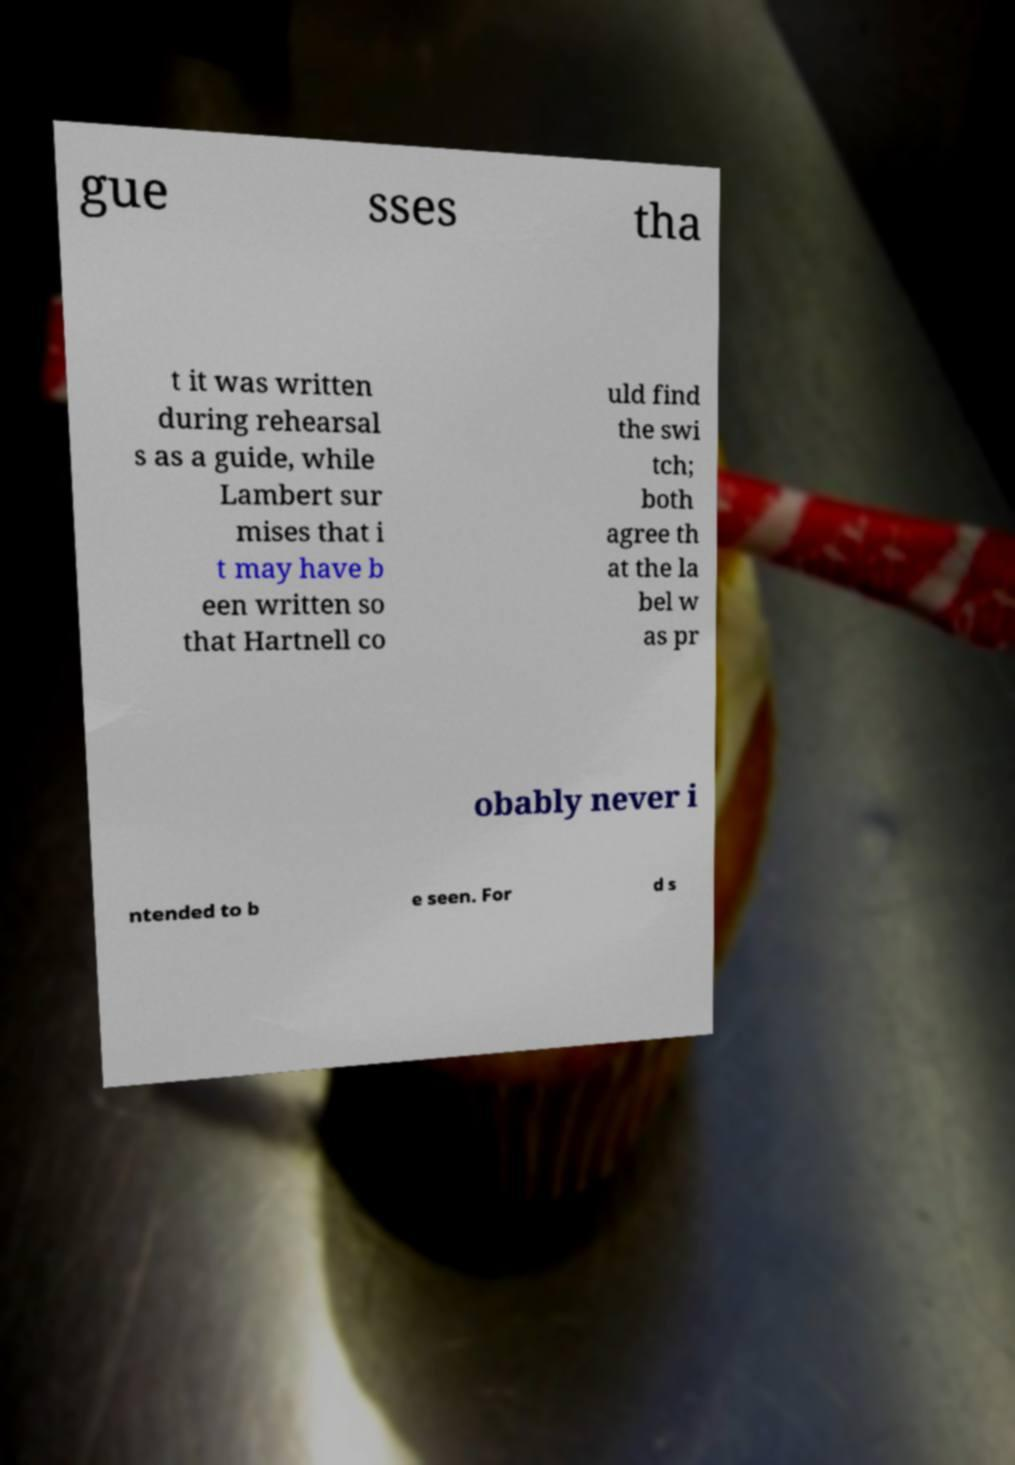Please identify and transcribe the text found in this image. gue sses tha t it was written during rehearsal s as a guide, while Lambert sur mises that i t may have b een written so that Hartnell co uld find the swi tch; both agree th at the la bel w as pr obably never i ntended to b e seen. For d s 